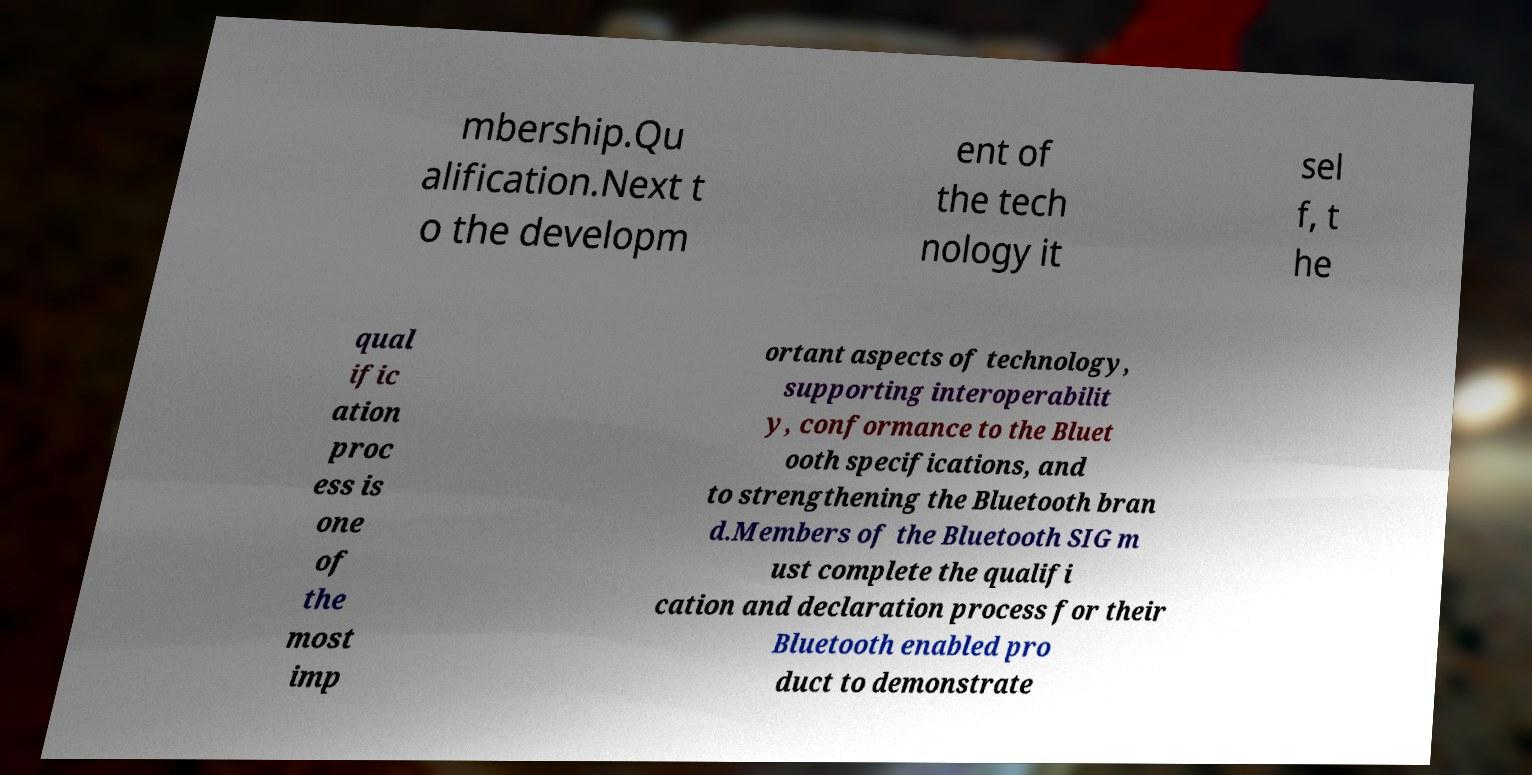Can you accurately transcribe the text from the provided image for me? mbership.Qu alification.Next t o the developm ent of the tech nology it sel f, t he qual ific ation proc ess is one of the most imp ortant aspects of technology, supporting interoperabilit y, conformance to the Bluet ooth specifications, and to strengthening the Bluetooth bran d.Members of the Bluetooth SIG m ust complete the qualifi cation and declaration process for their Bluetooth enabled pro duct to demonstrate 